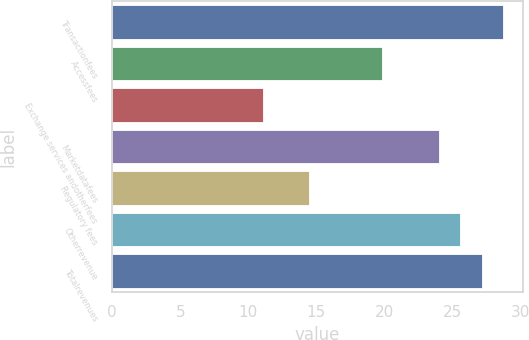Convert chart. <chart><loc_0><loc_0><loc_500><loc_500><bar_chart><fcel>Transactionfees<fcel>Accessfees<fcel>Exchange services andotherfees<fcel>Marketdatafees<fcel>Regulatory fees<fcel>Otherrevenue<fcel>Totalrevenues<nl><fcel>28.77<fcel>19.8<fcel>11.1<fcel>24<fcel>14.5<fcel>25.59<fcel>27.18<nl></chart> 